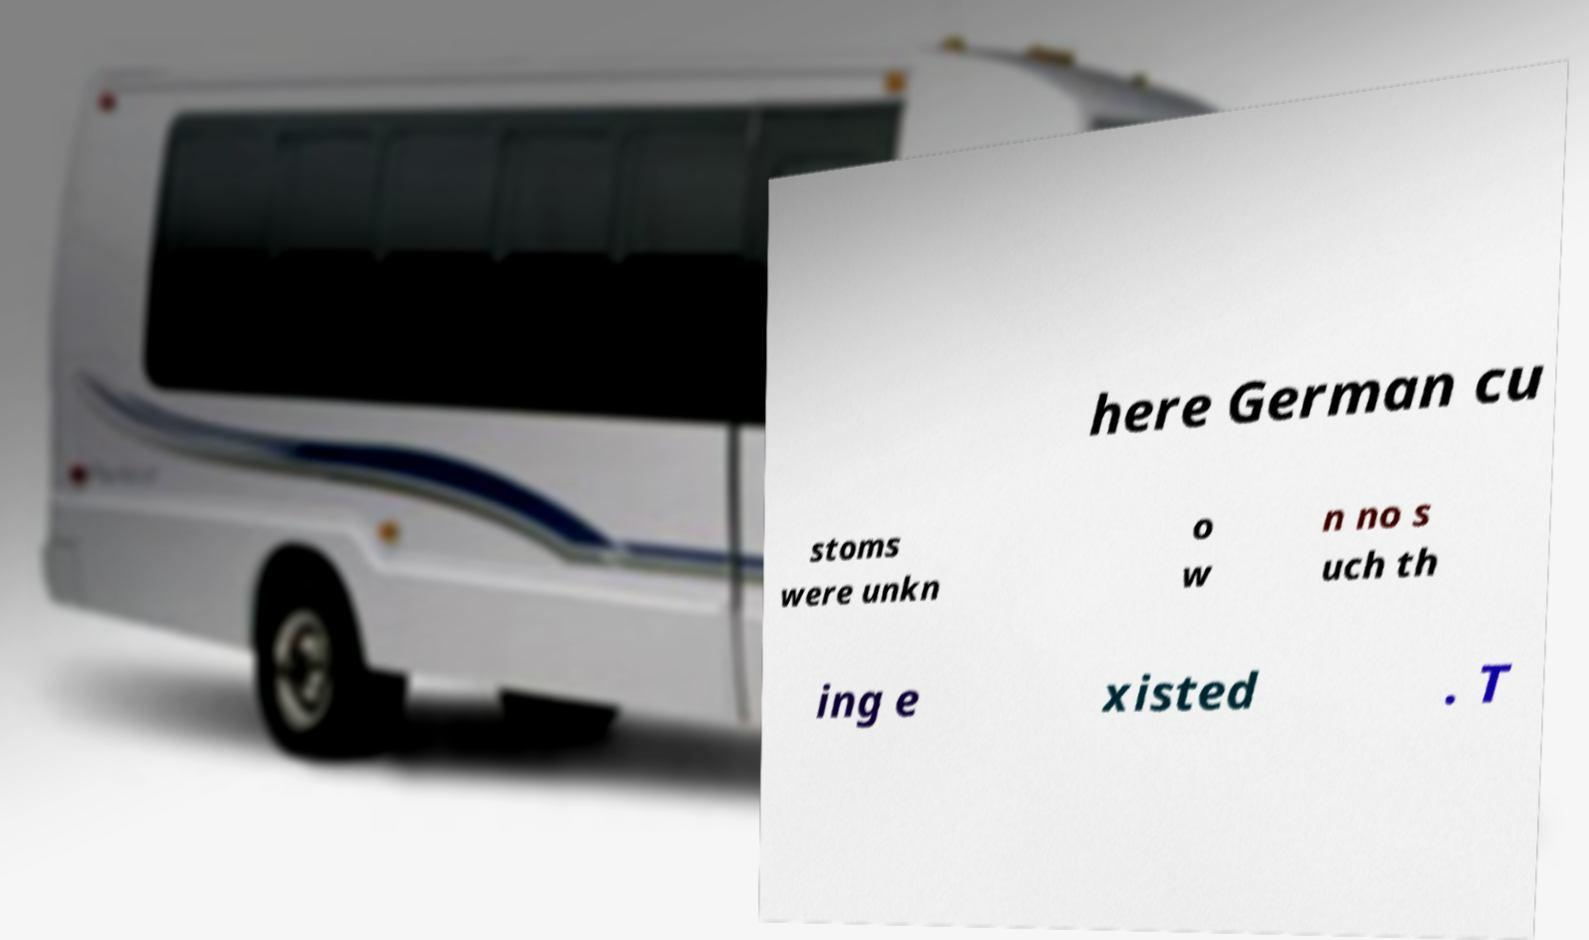Could you assist in decoding the text presented in this image and type it out clearly? here German cu stoms were unkn o w n no s uch th ing e xisted . T 